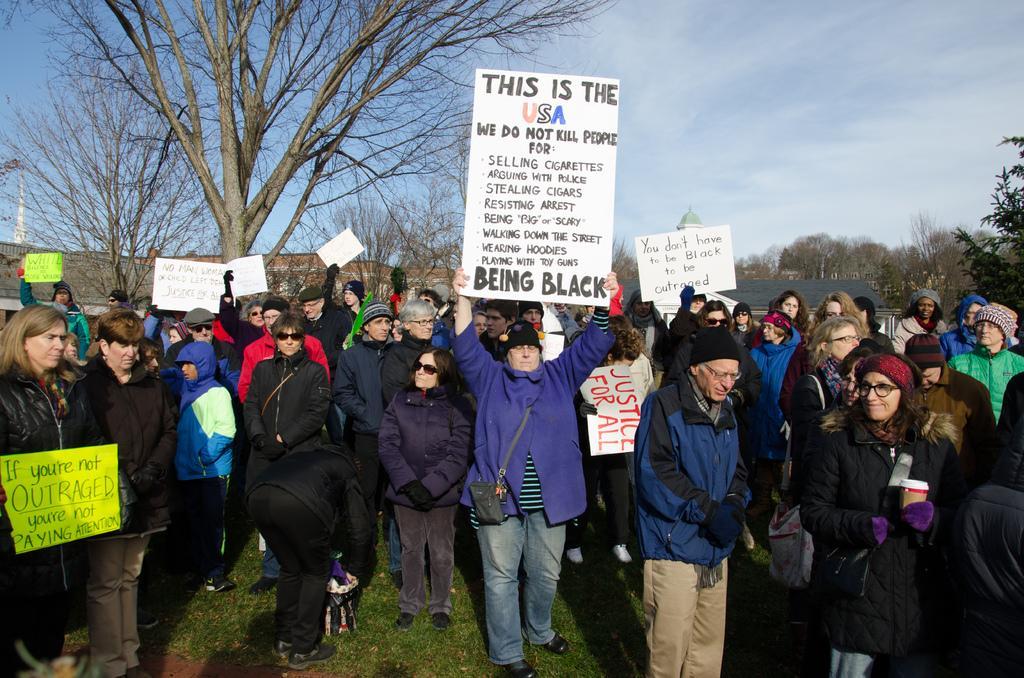In one or two sentences, can you explain what this image depicts? In the foreground of the picture we can see lot of people, they are holding placards. In the middle of the picture we can see trees and buildings. At the top there is sky. 